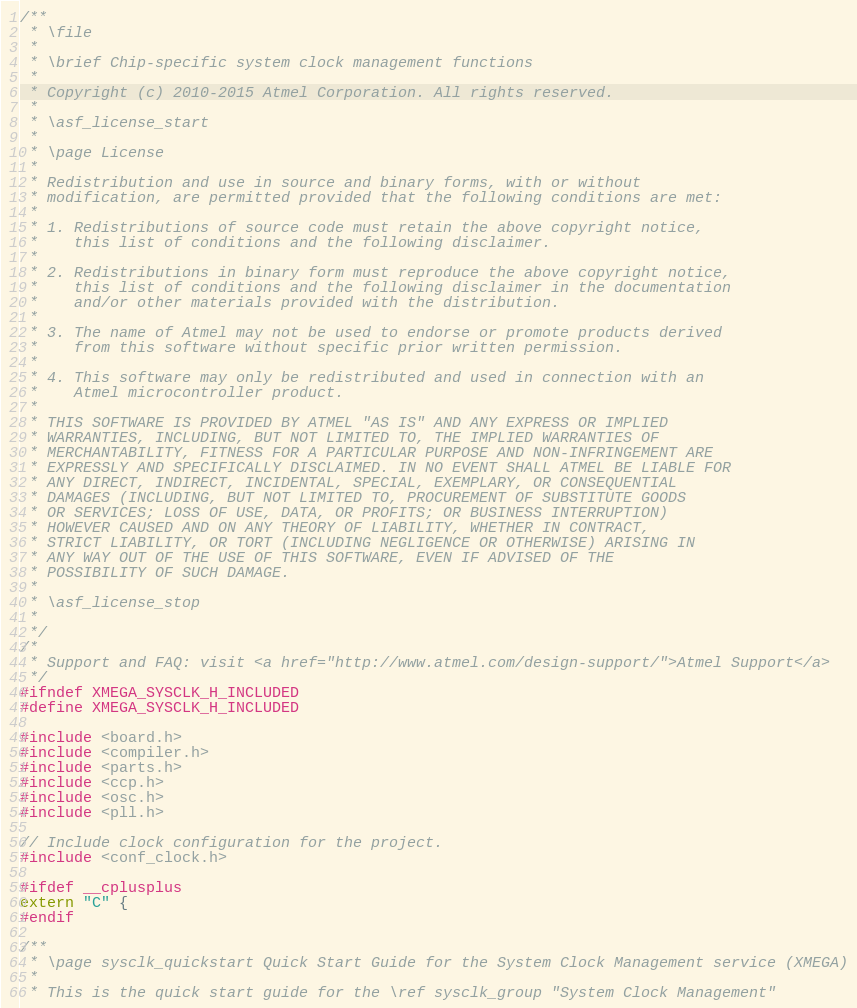Convert code to text. <code><loc_0><loc_0><loc_500><loc_500><_C_>/**
 * \file
 *
 * \brief Chip-specific system clock management functions
 *
 * Copyright (c) 2010-2015 Atmel Corporation. All rights reserved.
 *
 * \asf_license_start
 *
 * \page License
 *
 * Redistribution and use in source and binary forms, with or without
 * modification, are permitted provided that the following conditions are met:
 *
 * 1. Redistributions of source code must retain the above copyright notice,
 *    this list of conditions and the following disclaimer.
 *
 * 2. Redistributions in binary form must reproduce the above copyright notice,
 *    this list of conditions and the following disclaimer in the documentation
 *    and/or other materials provided with the distribution.
 *
 * 3. The name of Atmel may not be used to endorse or promote products derived
 *    from this software without specific prior written permission.
 *
 * 4. This software may only be redistributed and used in connection with an
 *    Atmel microcontroller product.
 *
 * THIS SOFTWARE IS PROVIDED BY ATMEL "AS IS" AND ANY EXPRESS OR IMPLIED
 * WARRANTIES, INCLUDING, BUT NOT LIMITED TO, THE IMPLIED WARRANTIES OF
 * MERCHANTABILITY, FITNESS FOR A PARTICULAR PURPOSE AND NON-INFRINGEMENT ARE
 * EXPRESSLY AND SPECIFICALLY DISCLAIMED. IN NO EVENT SHALL ATMEL BE LIABLE FOR
 * ANY DIRECT, INDIRECT, INCIDENTAL, SPECIAL, EXEMPLARY, OR CONSEQUENTIAL
 * DAMAGES (INCLUDING, BUT NOT LIMITED TO, PROCUREMENT OF SUBSTITUTE GOODS
 * OR SERVICES; LOSS OF USE, DATA, OR PROFITS; OR BUSINESS INTERRUPTION)
 * HOWEVER CAUSED AND ON ANY THEORY OF LIABILITY, WHETHER IN CONTRACT,
 * STRICT LIABILITY, OR TORT (INCLUDING NEGLIGENCE OR OTHERWISE) ARISING IN
 * ANY WAY OUT OF THE USE OF THIS SOFTWARE, EVEN IF ADVISED OF THE
 * POSSIBILITY OF SUCH DAMAGE.
 *
 * \asf_license_stop
 *
 */
/*
 * Support and FAQ: visit <a href="http://www.atmel.com/design-support/">Atmel Support</a>
 */
#ifndef XMEGA_SYSCLK_H_INCLUDED
#define XMEGA_SYSCLK_H_INCLUDED

#include <board.h>
#include <compiler.h>
#include <parts.h>
#include <ccp.h>
#include <osc.h>
#include <pll.h>

// Include clock configuration for the project.
#include <conf_clock.h>

#ifdef __cplusplus
extern "C" {
#endif

/**
 * \page sysclk_quickstart Quick Start Guide for the System Clock Management service (XMEGA)
 *
 * This is the quick start guide for the \ref sysclk_group "System Clock Management"</code> 